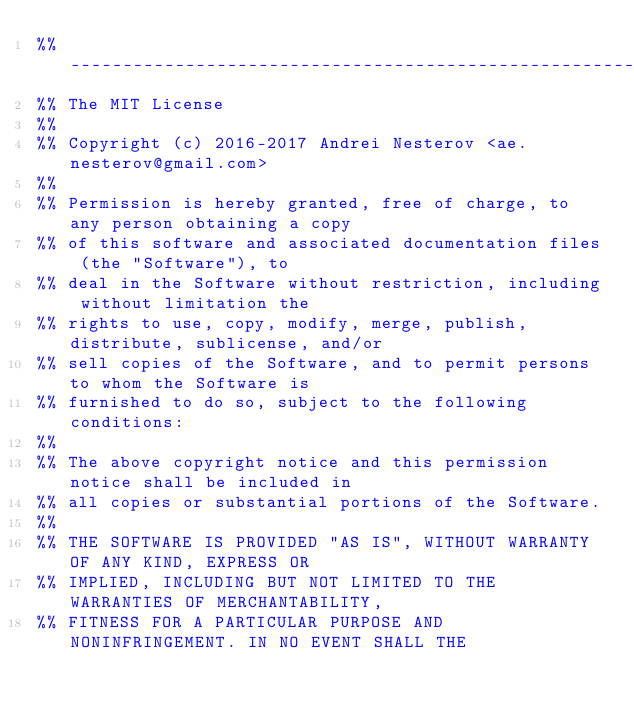Convert code to text. <code><loc_0><loc_0><loc_500><loc_500><_Erlang_>%% ----------------------------------------------------------------------------
%% The MIT License
%%
%% Copyright (c) 2016-2017 Andrei Nesterov <ae.nesterov@gmail.com>
%%
%% Permission is hereby granted, free of charge, to any person obtaining a copy
%% of this software and associated documentation files (the "Software"), to
%% deal in the Software without restriction, including without limitation the
%% rights to use, copy, modify, merge, publish, distribute, sublicense, and/or
%% sell copies of the Software, and to permit persons to whom the Software is
%% furnished to do so, subject to the following conditions:
%%
%% The above copyright notice and this permission notice shall be included in
%% all copies or substantial portions of the Software.
%%
%% THE SOFTWARE IS PROVIDED "AS IS", WITHOUT WARRANTY OF ANY KIND, EXPRESS OR
%% IMPLIED, INCLUDING BUT NOT LIMITED TO THE WARRANTIES OF MERCHANTABILITY,
%% FITNESS FOR A PARTICULAR PURPOSE AND NONINFRINGEMENT. IN NO EVENT SHALL THE</code> 